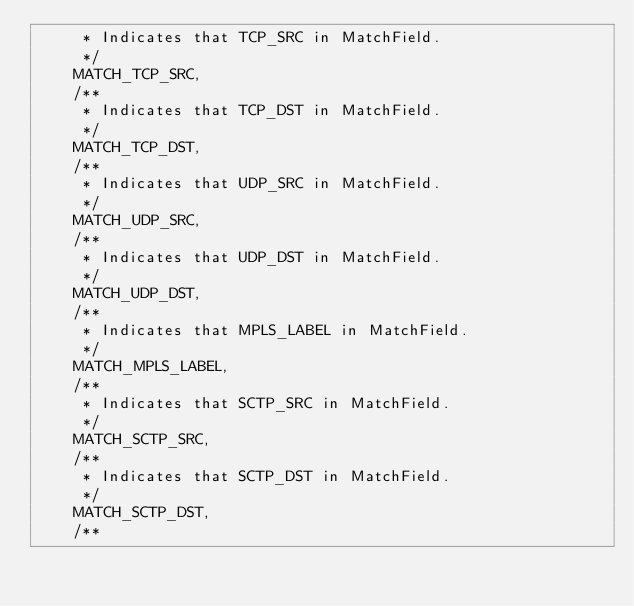Convert code to text. <code><loc_0><loc_0><loc_500><loc_500><_Java_>     * Indicates that TCP_SRC in MatchField.
     */
    MATCH_TCP_SRC,
    /**
     * Indicates that TCP_DST in MatchField.
     */
    MATCH_TCP_DST,
    /**
     * Indicates that UDP_SRC in MatchField.
     */
    MATCH_UDP_SRC,
    /**
     * Indicates that UDP_DST in MatchField.
     */
    MATCH_UDP_DST,
    /**
     * Indicates that MPLS_LABEL in MatchField.
     */
    MATCH_MPLS_LABEL,
    /**
     * Indicates that SCTP_SRC in MatchField.
     */
    MATCH_SCTP_SRC,
    /**
     * Indicates that SCTP_DST in MatchField.
     */
    MATCH_SCTP_DST,
    /**</code> 